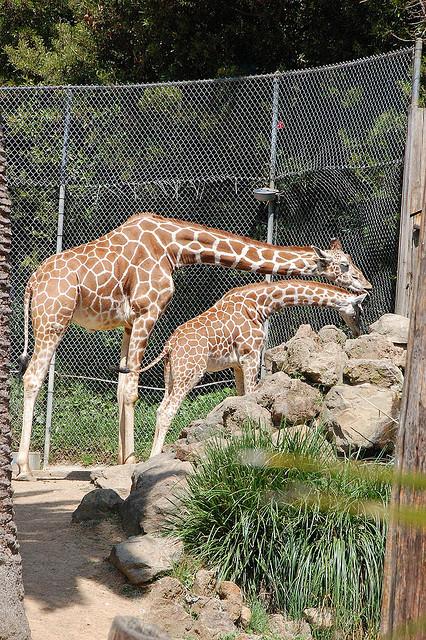What kind of animals are these?
Give a very brief answer. Giraffe. What are the animals doing?
Short answer required. Standing. Where are the rocks?
Quick response, please. On right. Are the giraffe's approximately the same size?
Short answer required. No. 